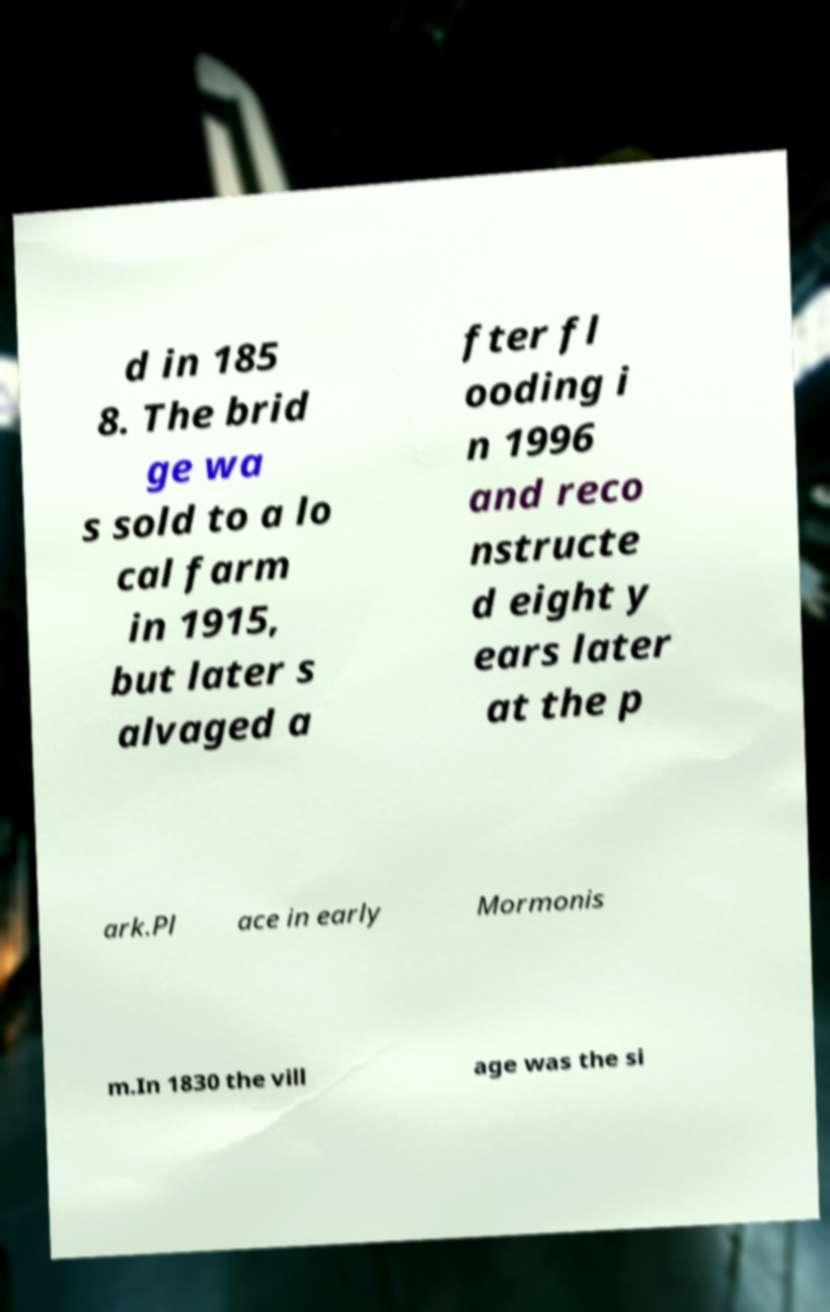Could you extract and type out the text from this image? d in 185 8. The brid ge wa s sold to a lo cal farm in 1915, but later s alvaged a fter fl ooding i n 1996 and reco nstructe d eight y ears later at the p ark.Pl ace in early Mormonis m.In 1830 the vill age was the si 